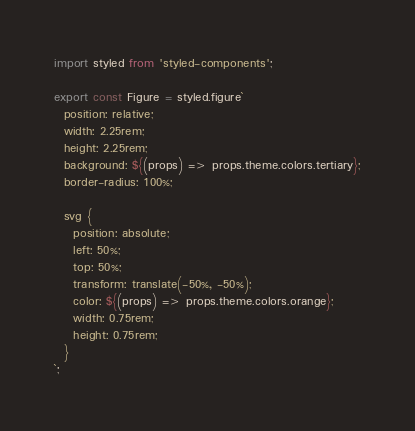Convert code to text. <code><loc_0><loc_0><loc_500><loc_500><_TypeScript_>import styled from 'styled-components';

export const Figure = styled.figure`
  position: relative;
  width: 2.25rem;
  height: 2.25rem;
  background: ${(props) => props.theme.colors.tertiary};
  border-radius: 100%;

  svg {
    position: absolute;
    left: 50%;
    top: 50%;
    transform: translate(-50%, -50%);
    color: ${(props) => props.theme.colors.orange};
    width: 0.75rem;
    height: 0.75rem;
  }
`;
</code> 